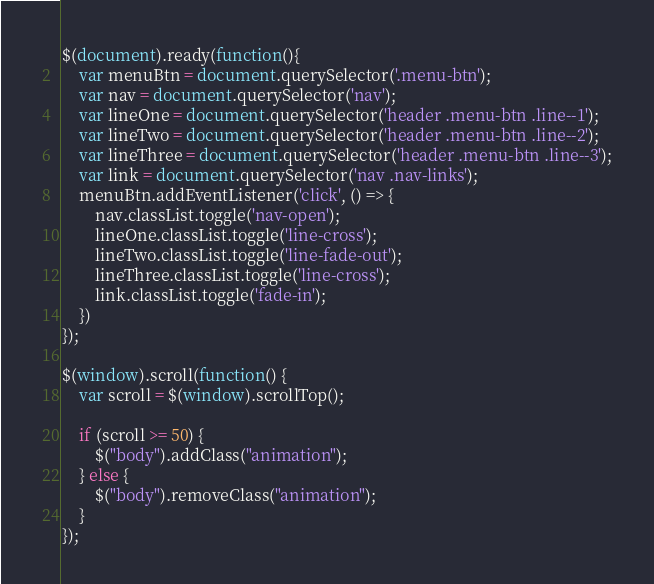<code> <loc_0><loc_0><loc_500><loc_500><_JavaScript_>$(document).ready(function(){     
    var menuBtn = document.querySelector('.menu-btn');
    var nav = document.querySelector('nav');
    var lineOne = document.querySelector('header .menu-btn .line--1');
    var lineTwo = document.querySelector('header .menu-btn .line--2');
    var lineThree = document.querySelector('header .menu-btn .line--3');
    var link = document.querySelector('nav .nav-links');
    menuBtn.addEventListener('click', () => {
        nav.classList.toggle('nav-open');
        lineOne.classList.toggle('line-cross');
        lineTwo.classList.toggle('line-fade-out');
        lineThree.classList.toggle('line-cross');
        link.classList.toggle('fade-in');
    })
});

$(window).scroll(function() {    
    var scroll = $(window).scrollTop();

    if (scroll >= 50) {
        $("body").addClass("animation");
    } else {
        $("body").removeClass("animation");
    }
});
</code> 